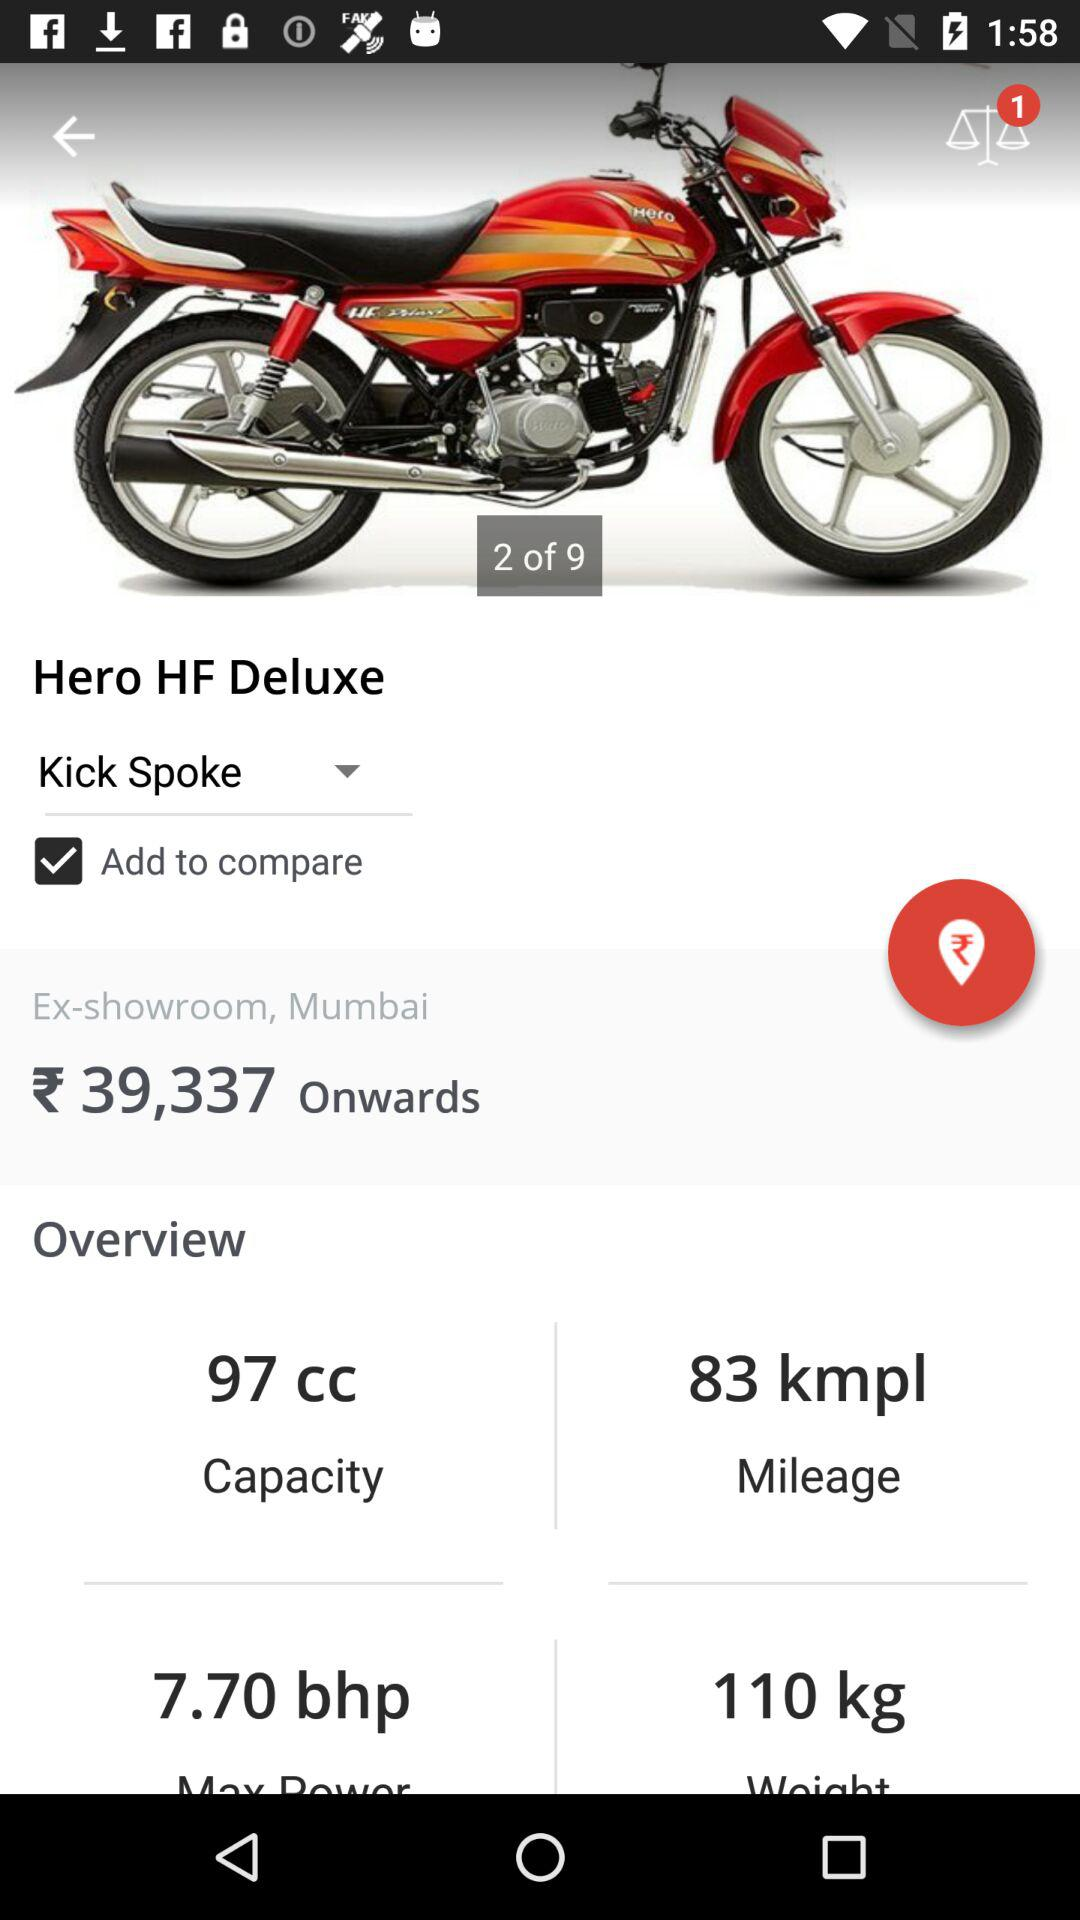How many kmpl does the Hero HF Deluxe get?
Answer the question using a single word or phrase. 83 kmpl 